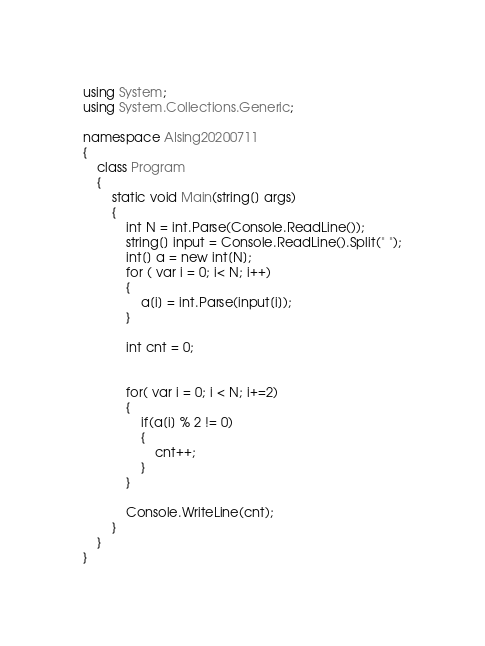Convert code to text. <code><loc_0><loc_0><loc_500><loc_500><_C#_>using System;
using System.Collections.Generic;

namespace AIsing20200711
{
    class Program
    {
        static void Main(string[] args)
        {
            int N = int.Parse(Console.ReadLine());
            string[] input = Console.ReadLine().Split(" ");
            int[] a = new int[N];
            for ( var i = 0; i< N; i++)
            {
                a[i] = int.Parse(input[i]);
            }

            int cnt = 0;


            for( var i = 0; i < N; i+=2)
            {
                if(a[i] % 2 != 0)
                {
                    cnt++;
                }
            }

            Console.WriteLine(cnt);
        }
    }
}
</code> 